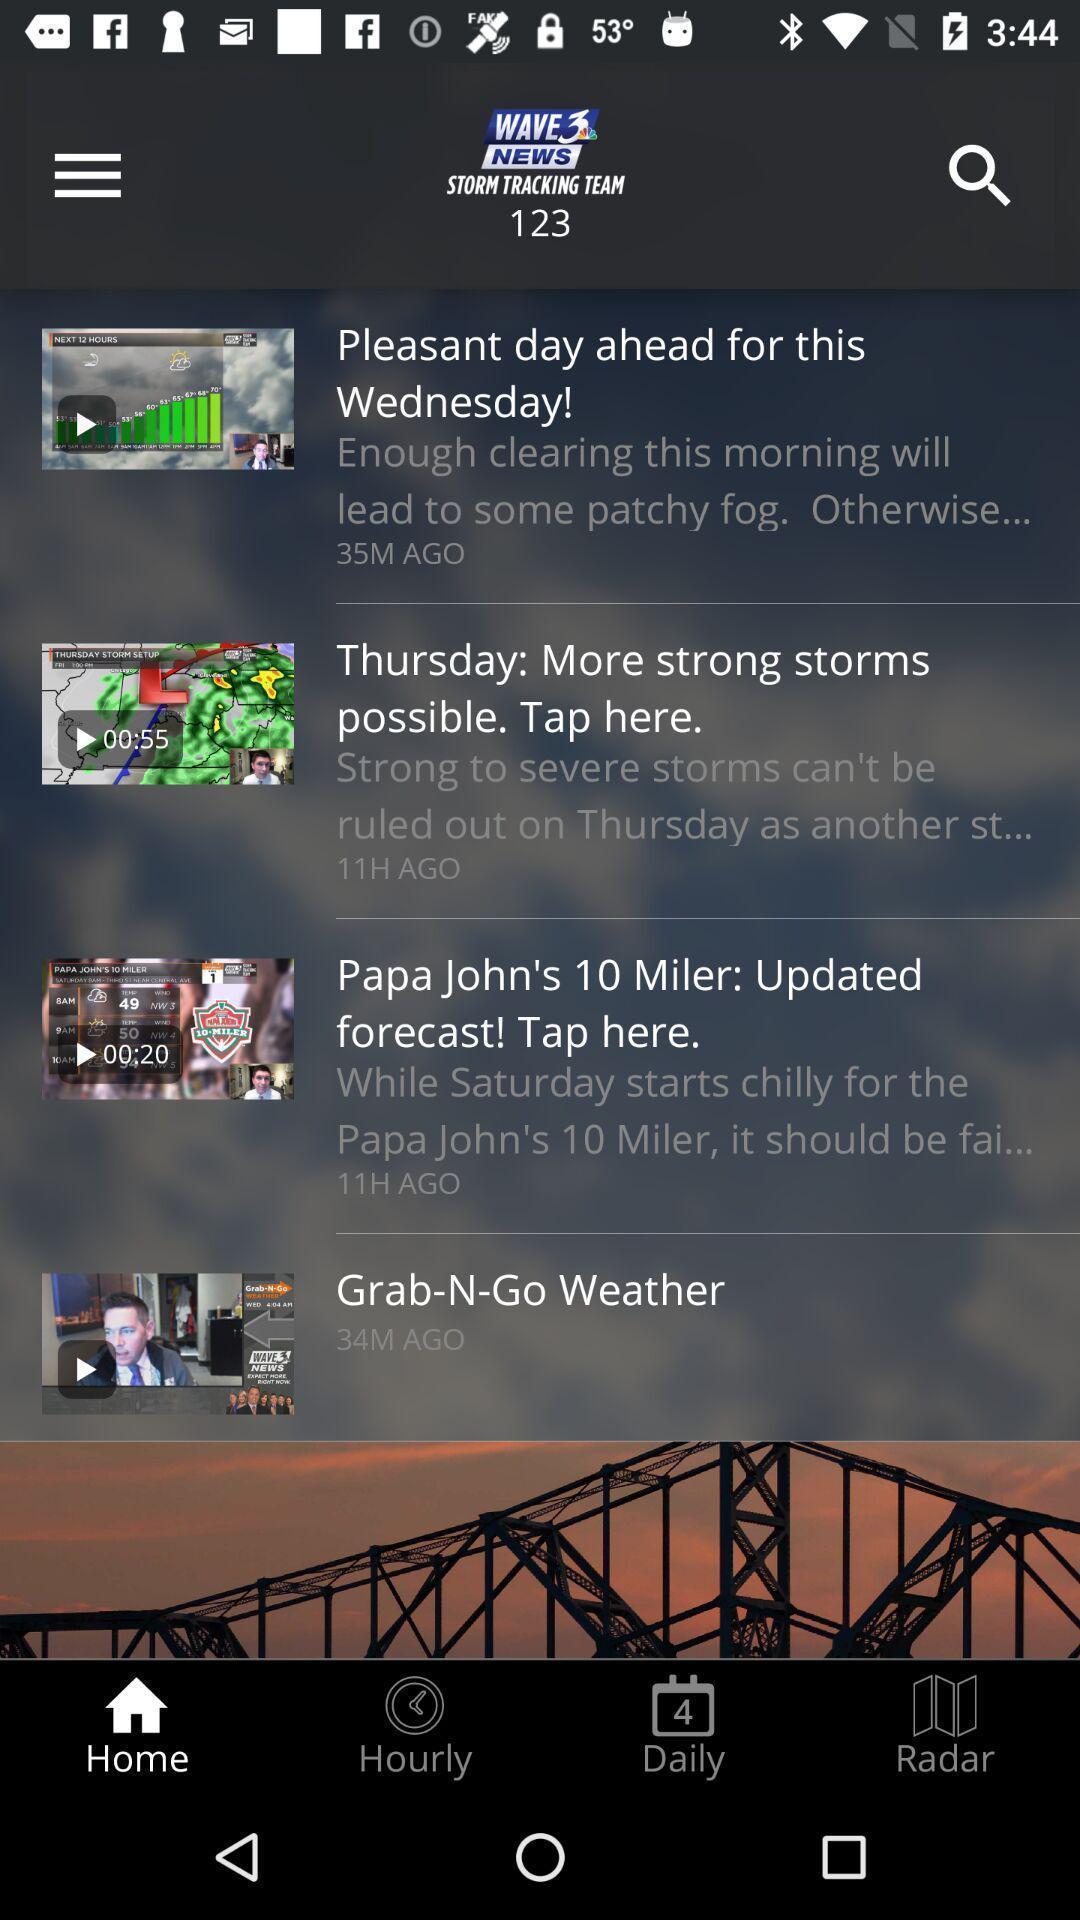Provide a description of this screenshot. Window displaying a weather app. 